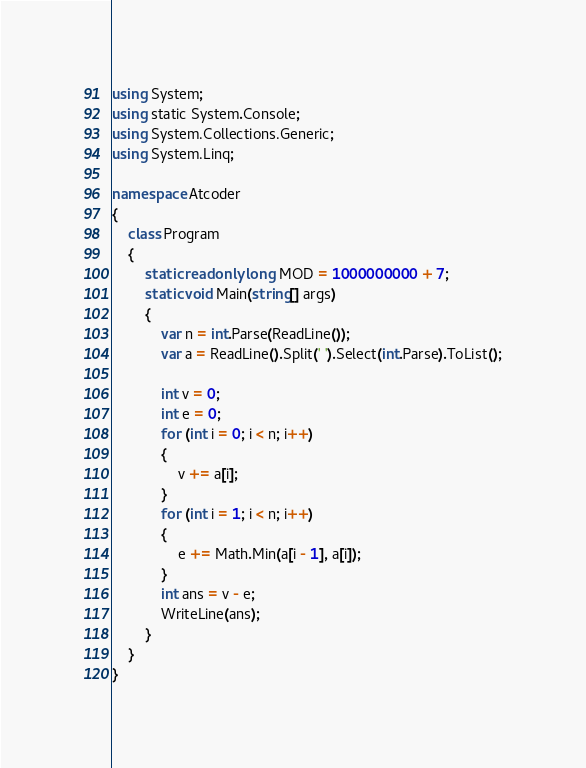Convert code to text. <code><loc_0><loc_0><loc_500><loc_500><_C#_>using System;
using static System.Console;
using System.Collections.Generic;
using System.Linq;

namespace Atcoder
{
    class Program
    {
        static readonly long MOD = 1000000000 + 7;
        static void Main(string[] args)
        {
            var n = int.Parse(ReadLine());
            var a = ReadLine().Split(' ').Select(int.Parse).ToList();

            int v = 0;
            int e = 0;
            for (int i = 0; i < n; i++)
            {
                v += a[i];
            }
            for (int i = 1; i < n; i++)
            {
                e += Math.Min(a[i - 1], a[i]);
            }
            int ans = v - e;
            WriteLine(ans);
        }
    }
}

</code> 